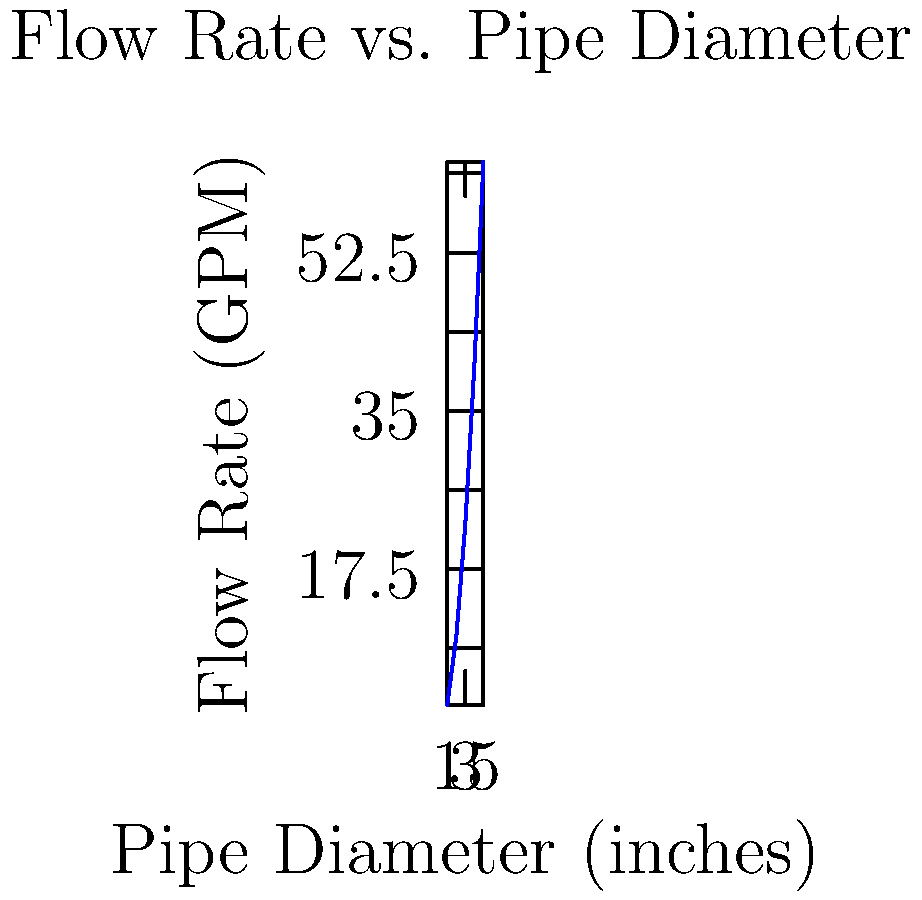As a seed merchant specializing in rare and exotic plant varieties, you're designing an irrigation system for a botanist's experimental greenhouse. The system requires a flow rate of 35 GPM. Using the graph provided, which shows the relationship between pipe diameter and flow rate at a constant pressure, estimate the minimum pipe diameter needed for the irrigation system. To solve this problem, we'll follow these steps:

1. Identify the target flow rate: 35 GPM

2. Locate 35 GPM on the y-axis (Flow Rate)

3. Move horizontally from this point until we intersect the blue curve

4. From the intersection point, drop a vertical line to the x-axis (Pipe Diameter)

5. Read the corresponding pipe diameter value

Looking at the graph:
- 35 GPM falls between the 22.5 GPM and 40 GPM marks on the y-axis
- Drawing a horizontal line from 35 GPM intersects the curve between the 3-inch and 4-inch marks on the x-axis
- The intersection appears to be closer to the 4-inch mark

Therefore, the minimum pipe diameter needed to achieve a flow rate of 35 GPM is approximately 3.75 inches.

Note: In practice, you would round up to the nearest available pipe size, which would likely be 4 inches, to ensure adequate flow and account for potential pressure losses in the system.
Answer: $3.75$ inches 